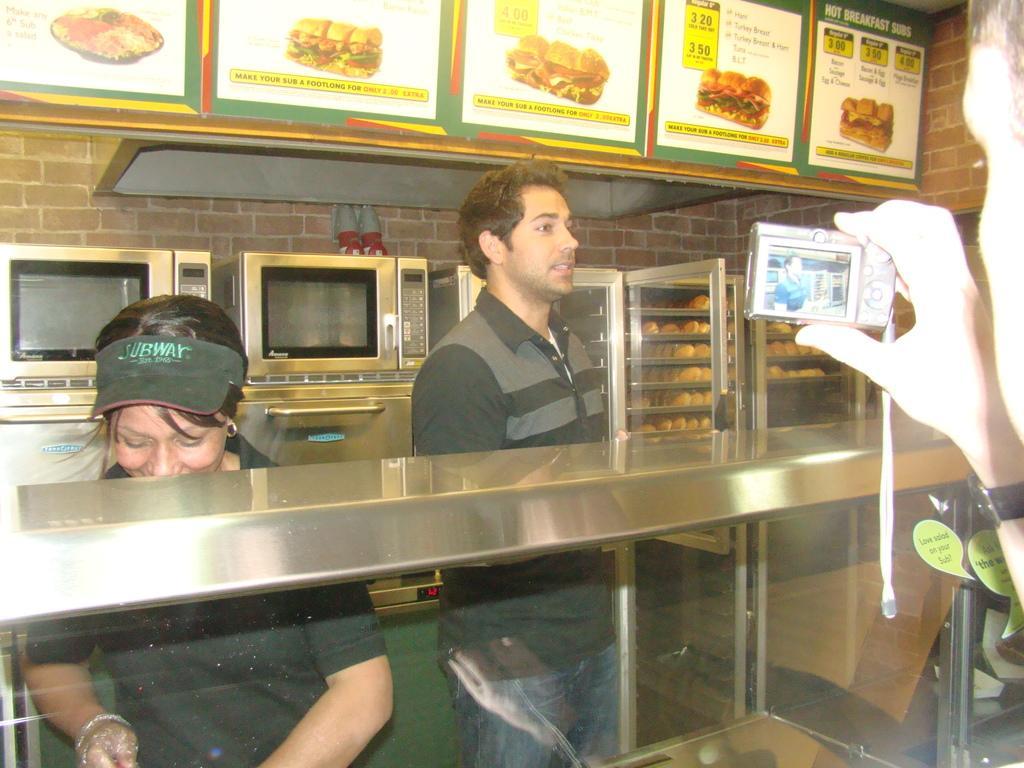Describe this image in one or two sentences. In this image there is a person holding a camera. Before him there is a glass table. Behind there is a woman wearing a cap. Beside her there is a person standing on the floor. Behind them there are ovens on the shelf. Right side there is a rack having some food. Top of the image there are boards attached to the wall. On the boards, there are pictures of food and some text. 